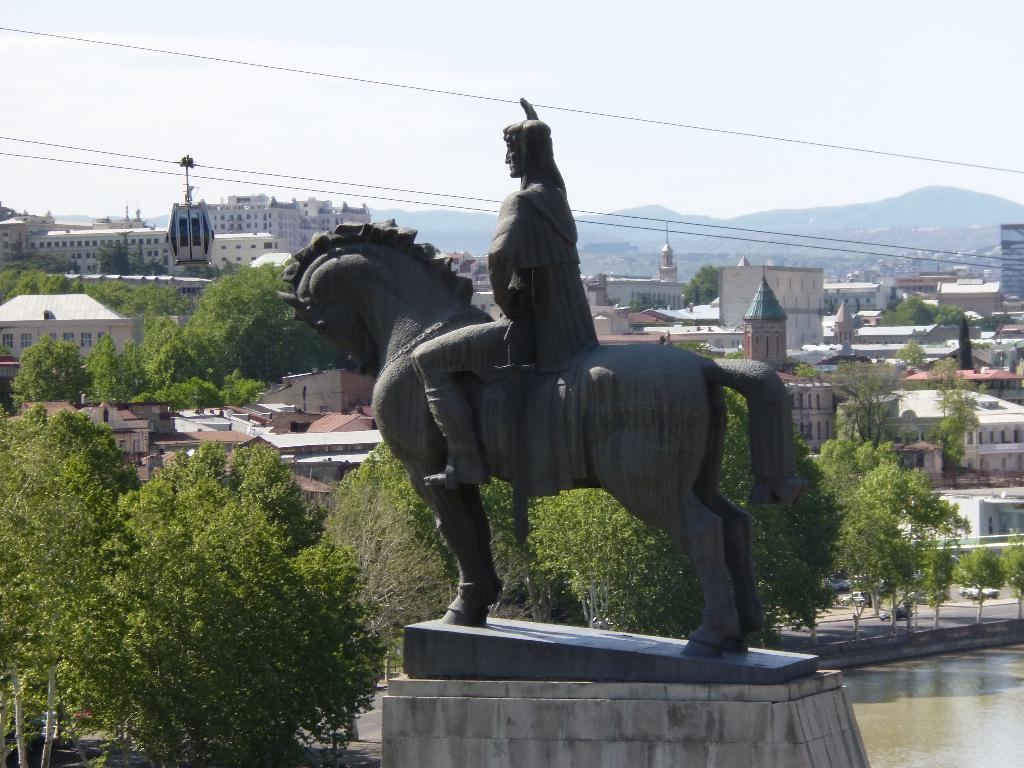What is the main subject of the image? There is a statue in the image. How is the statue positioned in the image? The statue is on a pedestal. What natural element can be seen in the image? There is water visible in the image. What type of man-made structures are present in the image? Buildings and sheds are in the image. What mode of transportation can be seen in the image? Motor vehicles are present on the road. What geographical feature is visible in the image? Hills are visible in the geographical feature visible in the image. What is the condition of the sky in the image? The sky is visible in the image, and clouds are present. What type of camp can be seen in the image? There is no camp present in the image. What emotion does the statue express in the image? The statue is an inanimate object and does not express emotions. 